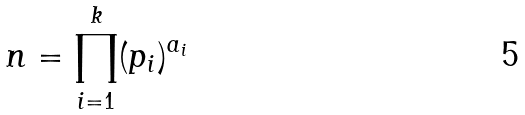Convert formula to latex. <formula><loc_0><loc_0><loc_500><loc_500>n = \prod _ { i = 1 } ^ { k } ( p _ { i } ) ^ { a _ { i } }</formula> 